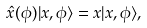Convert formula to latex. <formula><loc_0><loc_0><loc_500><loc_500>\hat { x } ( \phi ) | x , \phi \rangle = x | x , \phi \rangle ,</formula> 